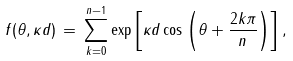Convert formula to latex. <formula><loc_0><loc_0><loc_500><loc_500>f ( \theta , \kappa d ) \, = \, \sum _ { k = 0 } ^ { n - 1 } \exp \left [ \kappa d \cos \left ( \theta + \frac { 2 k \pi } { n } \right ) \right ] ,</formula> 